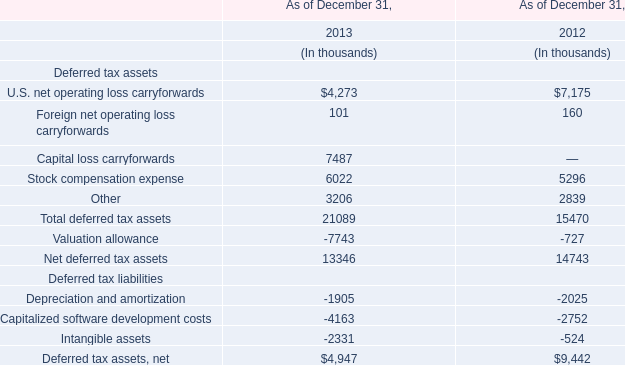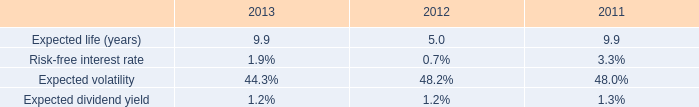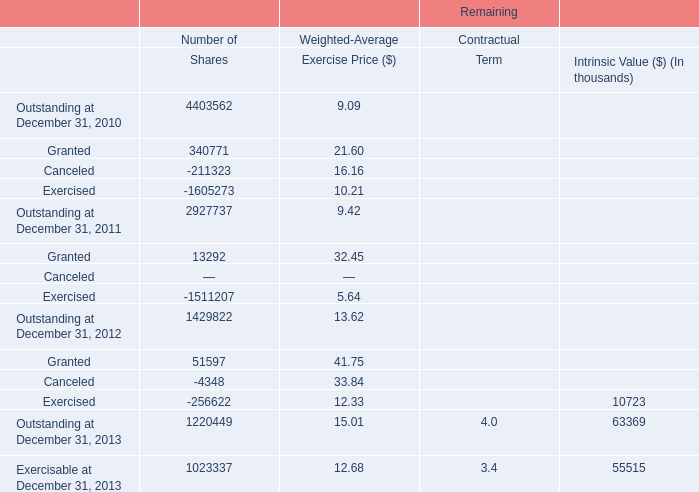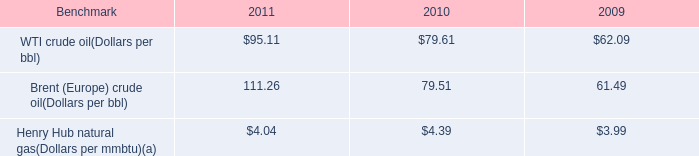by how much did the brent crude oil benchmark increase from 2010 to 2011? 
Computations: ((111.26 - 79.51) / 79.51)
Answer: 0.39932. 